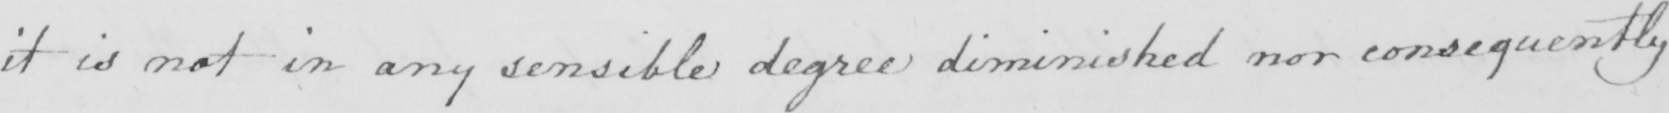What text is written in this handwritten line? it is not in any sensible degree diminished nor consequently 